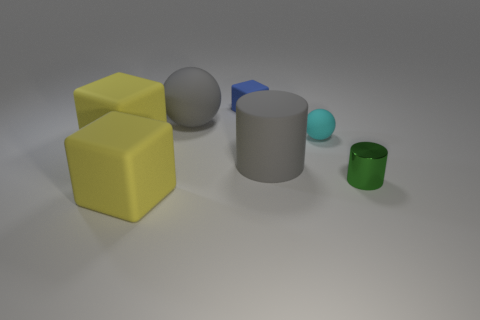Subtract all small matte cubes. How many cubes are left? 2 Add 2 large gray spheres. How many objects exist? 9 Subtract all purple balls. How many yellow blocks are left? 2 Subtract all gray spheres. How many spheres are left? 1 Subtract all blocks. How many objects are left? 4 Subtract 2 blocks. How many blocks are left? 1 Subtract all brown balls. Subtract all green blocks. How many balls are left? 2 Subtract all big balls. Subtract all tiny cyan matte things. How many objects are left? 5 Add 4 gray rubber things. How many gray rubber things are left? 6 Add 1 big purple rubber things. How many big purple rubber things exist? 1 